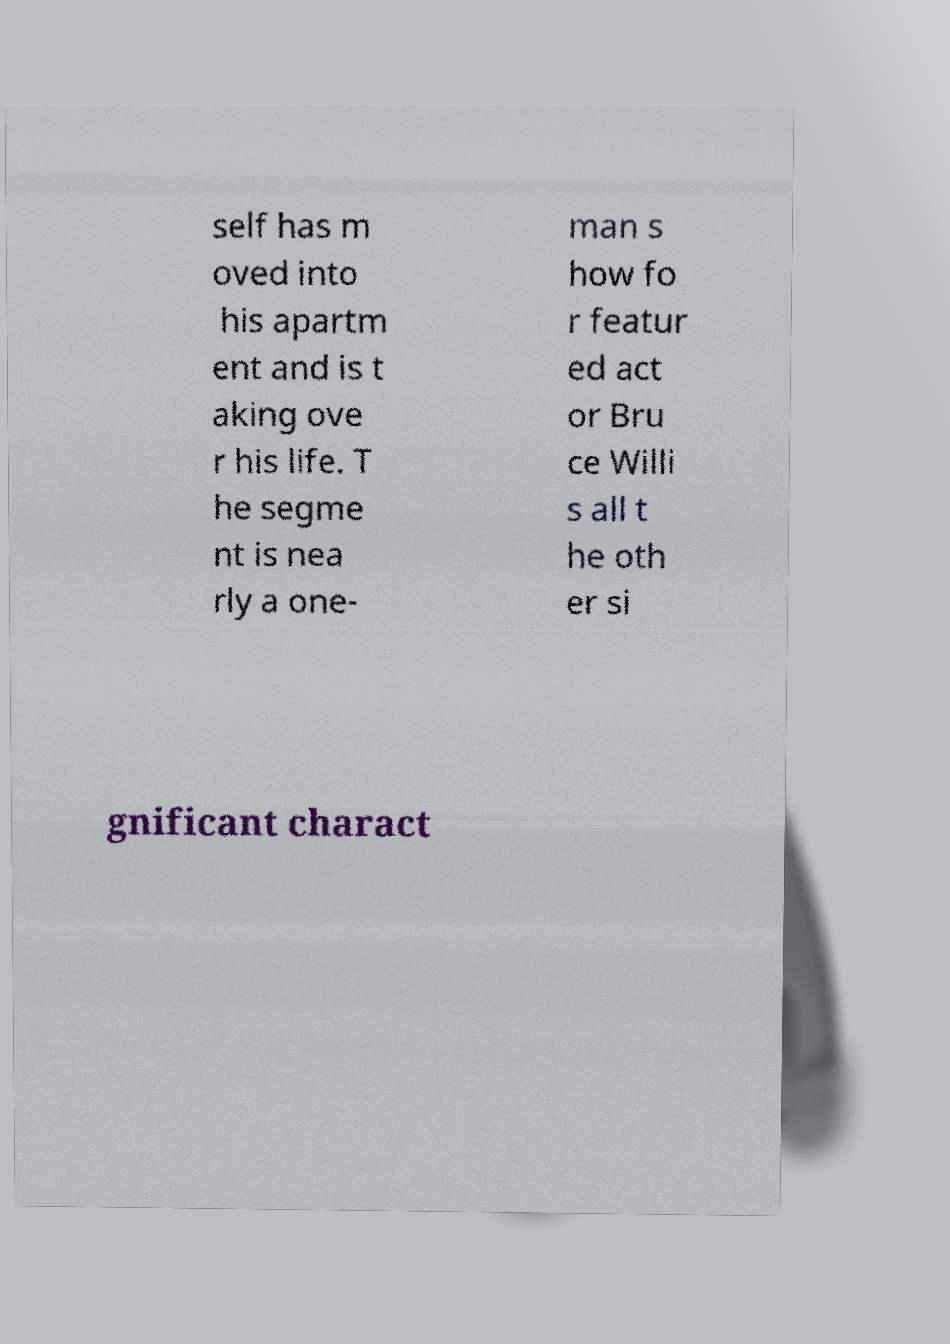I need the written content from this picture converted into text. Can you do that? self has m oved into his apartm ent and is t aking ove r his life. T he segme nt is nea rly a one- man s how fo r featur ed act or Bru ce Willi s all t he oth er si gnificant charact 